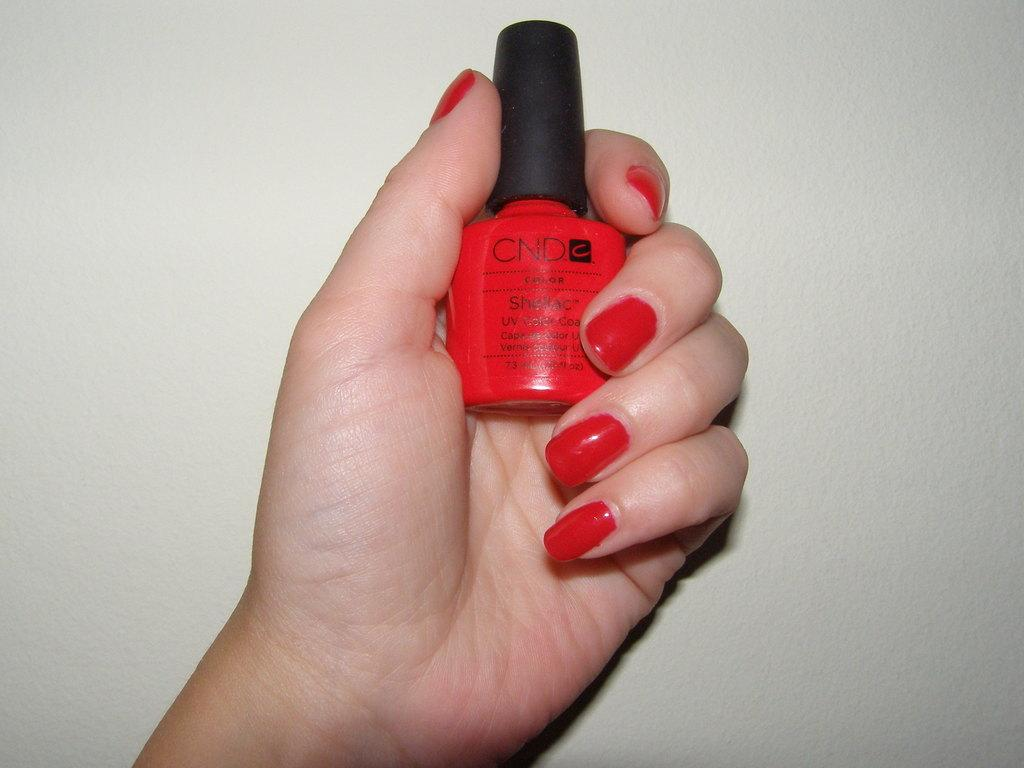What is the person holding in the image? There is a hand holding a nail polish bottle in the image. What is the purpose of the nail polish bottle? The nail polish bottle is likely being used to apply nail polish. Can you describe the nails in the image? Nail polish is visible on the nails. What is visible in the background of the image? There is a wall in the background of the image. Where is the park located in the image? There is no park present in the image; it only features a hand holding a nail polish bottle and a wall in the background. 